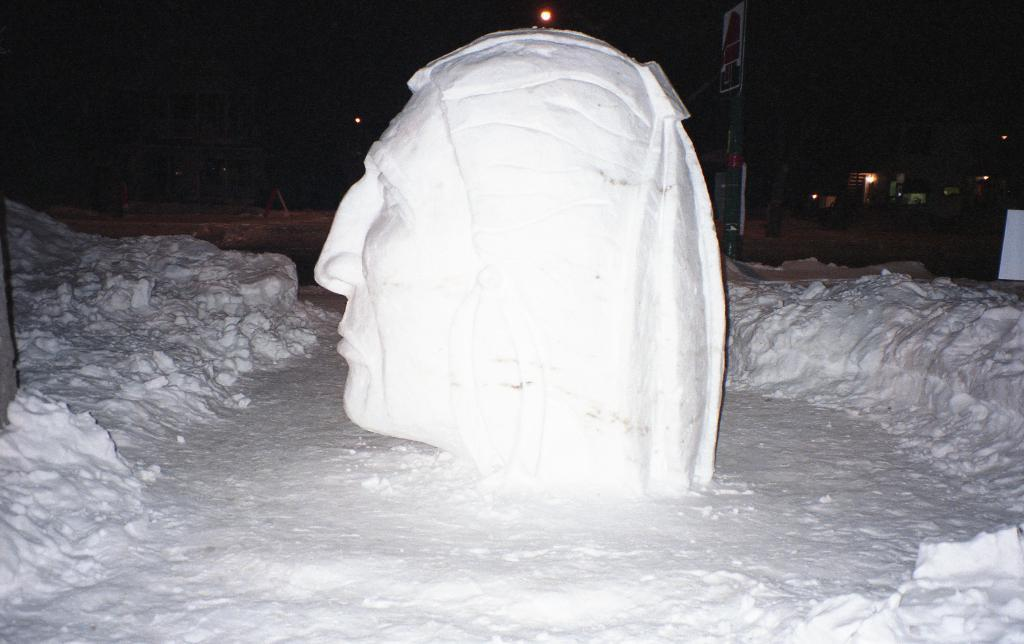What is the main subject of the image? There is a sculpture of a face in the image. What color is the sculpture? The sculpture is white in color. What is the condition of the ground around the sculpture? There is snow around the sculpture. How would you describe the lighting in the image? There are lights visible in the image. What can be inferred about the time of day or weather from the image? The background of the image is dark, and there is snow on the ground, which suggests a cold and possibly nighttime setting. What type of vegetable is being used to make the sculpture in the image? There is no vegetable present in the image; the sculpture is made of a different material, likely stone or metal. 